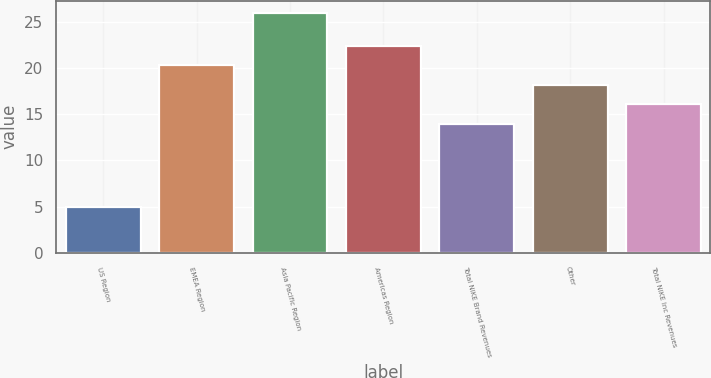Convert chart. <chart><loc_0><loc_0><loc_500><loc_500><bar_chart><fcel>US Region<fcel>EMEA Region<fcel>Asia Pacific Region<fcel>Americas Region<fcel>Total NIKE Brand Revenues<fcel>Other<fcel>Total NIKE Inc Revenues<nl><fcel>5<fcel>20.3<fcel>26<fcel>22.4<fcel>14<fcel>18.2<fcel>16.1<nl></chart> 